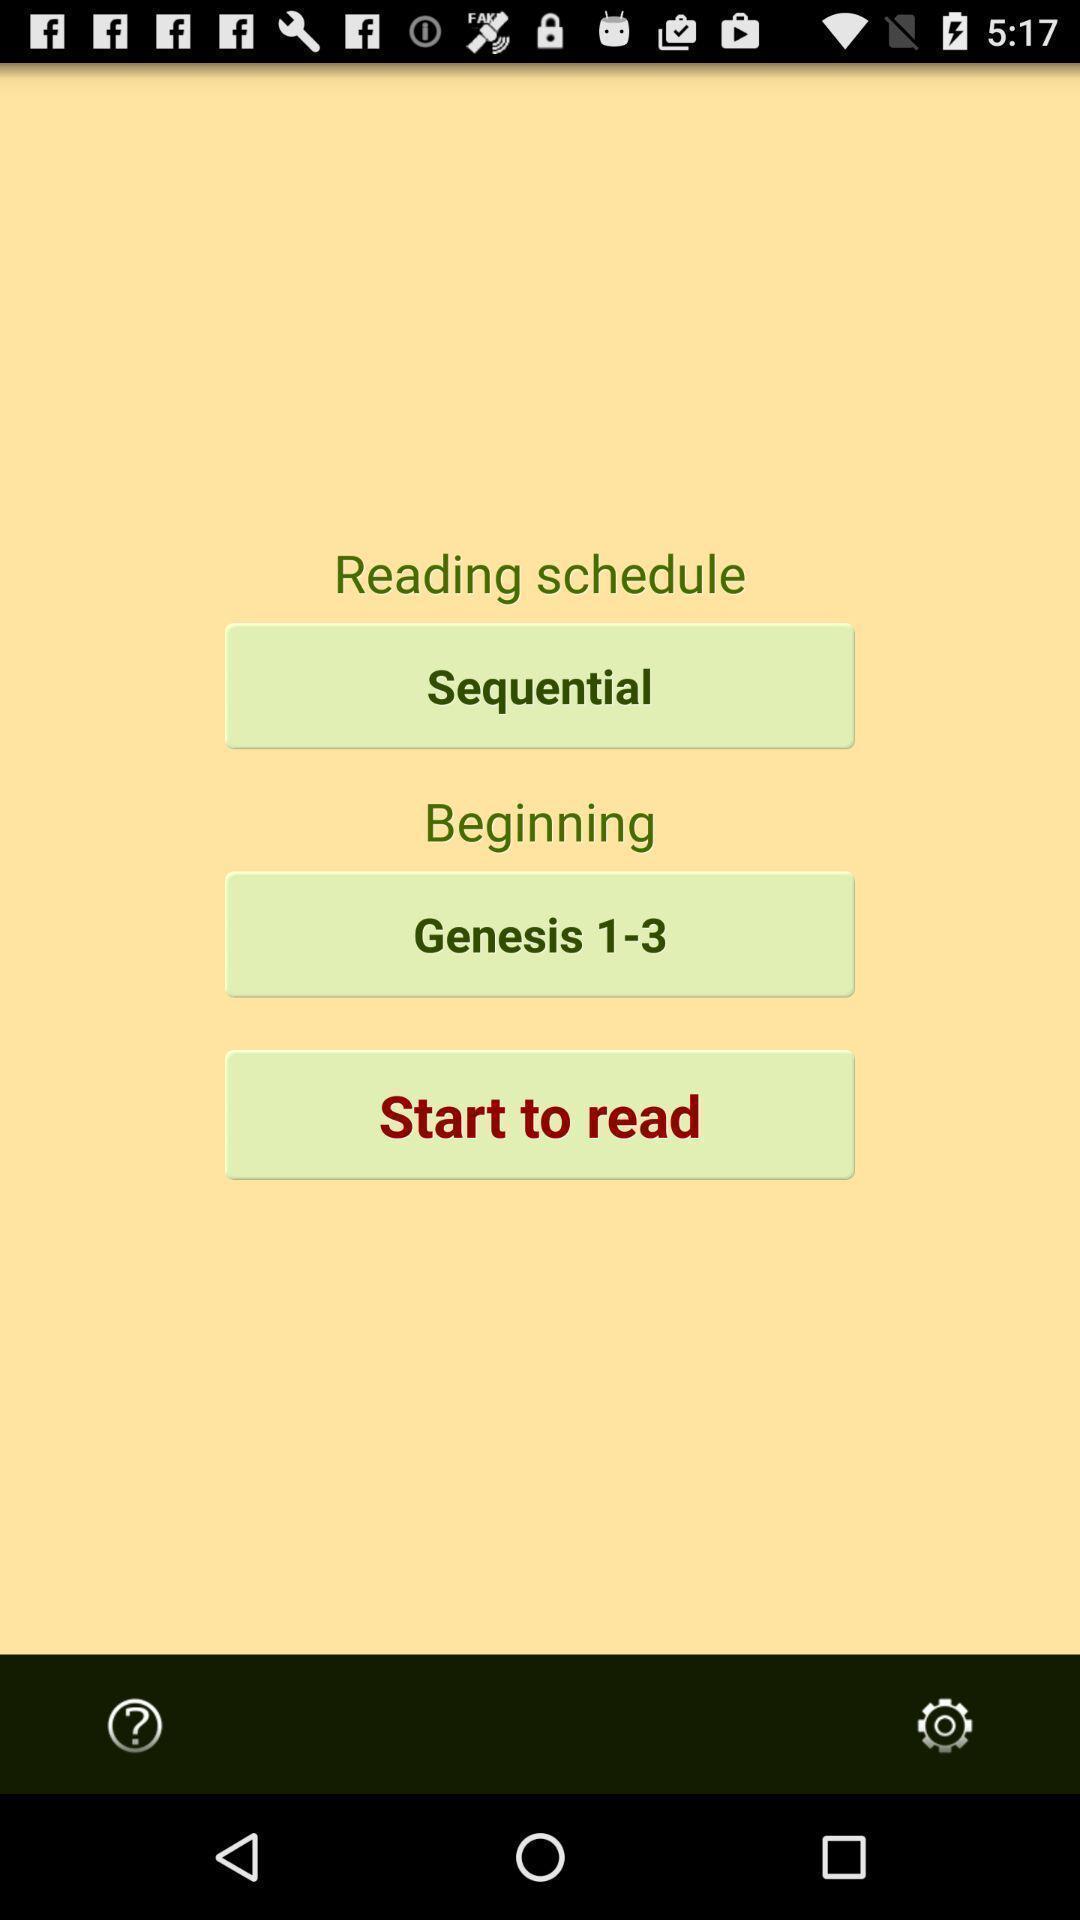What is the overall content of this screenshot? Various schedules for reading in application. 